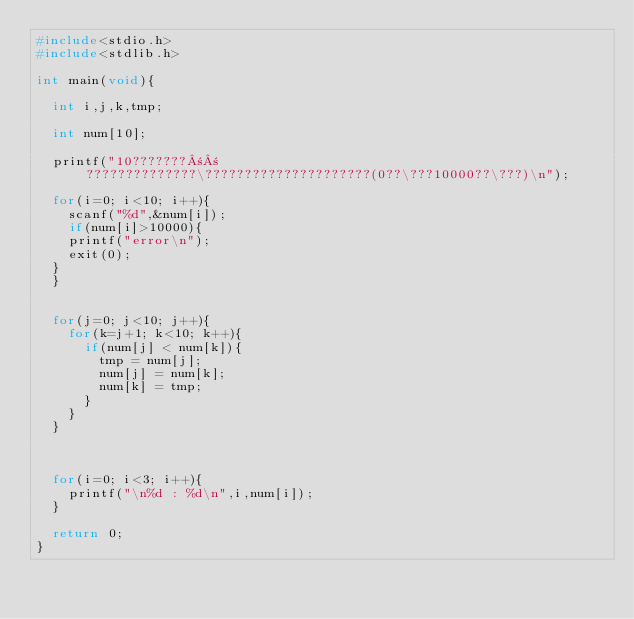Convert code to text. <code><loc_0><loc_0><loc_500><loc_500><_C_>#include<stdio.h>
#include<stdlib.h>

int main(void){

  int i,j,k,tmp;

  int num[10];

  printf("10???????±±??????????????\?????????????????????(0??\???10000??\???)\n");

  for(i=0; i<10; i++){
    scanf("%d",&num[i]);
    if(num[i]>10000){
		printf("error\n");
		exit(0);
	}
  }


  for(j=0; j<10; j++){
    for(k=j+1; k<10; k++){
      if(num[j] < num[k]){
        tmp = num[j];
        num[j] = num[k];
        num[k] = tmp;
      }
    }
  }
  
  
  
  for(i=0; i<3; i++){
    printf("\n%d : %d\n",i,num[i]);
  }

  return 0;
}</code> 